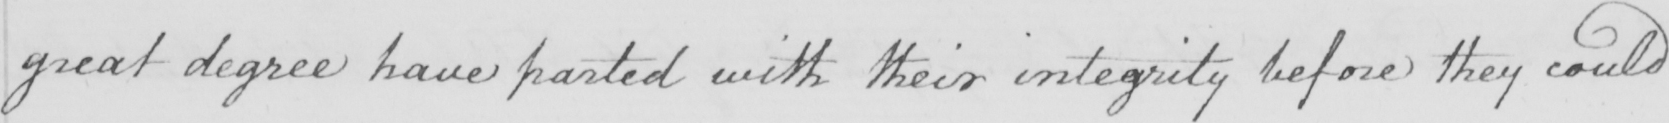Can you tell me what this handwritten text says? great degree have parted with their integrity before they could 